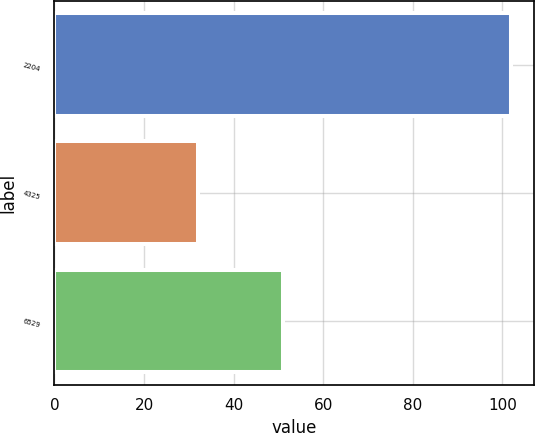Convert chart. <chart><loc_0><loc_0><loc_500><loc_500><bar_chart><fcel>2204<fcel>4325<fcel>6529<nl><fcel>102<fcel>32<fcel>51<nl></chart> 